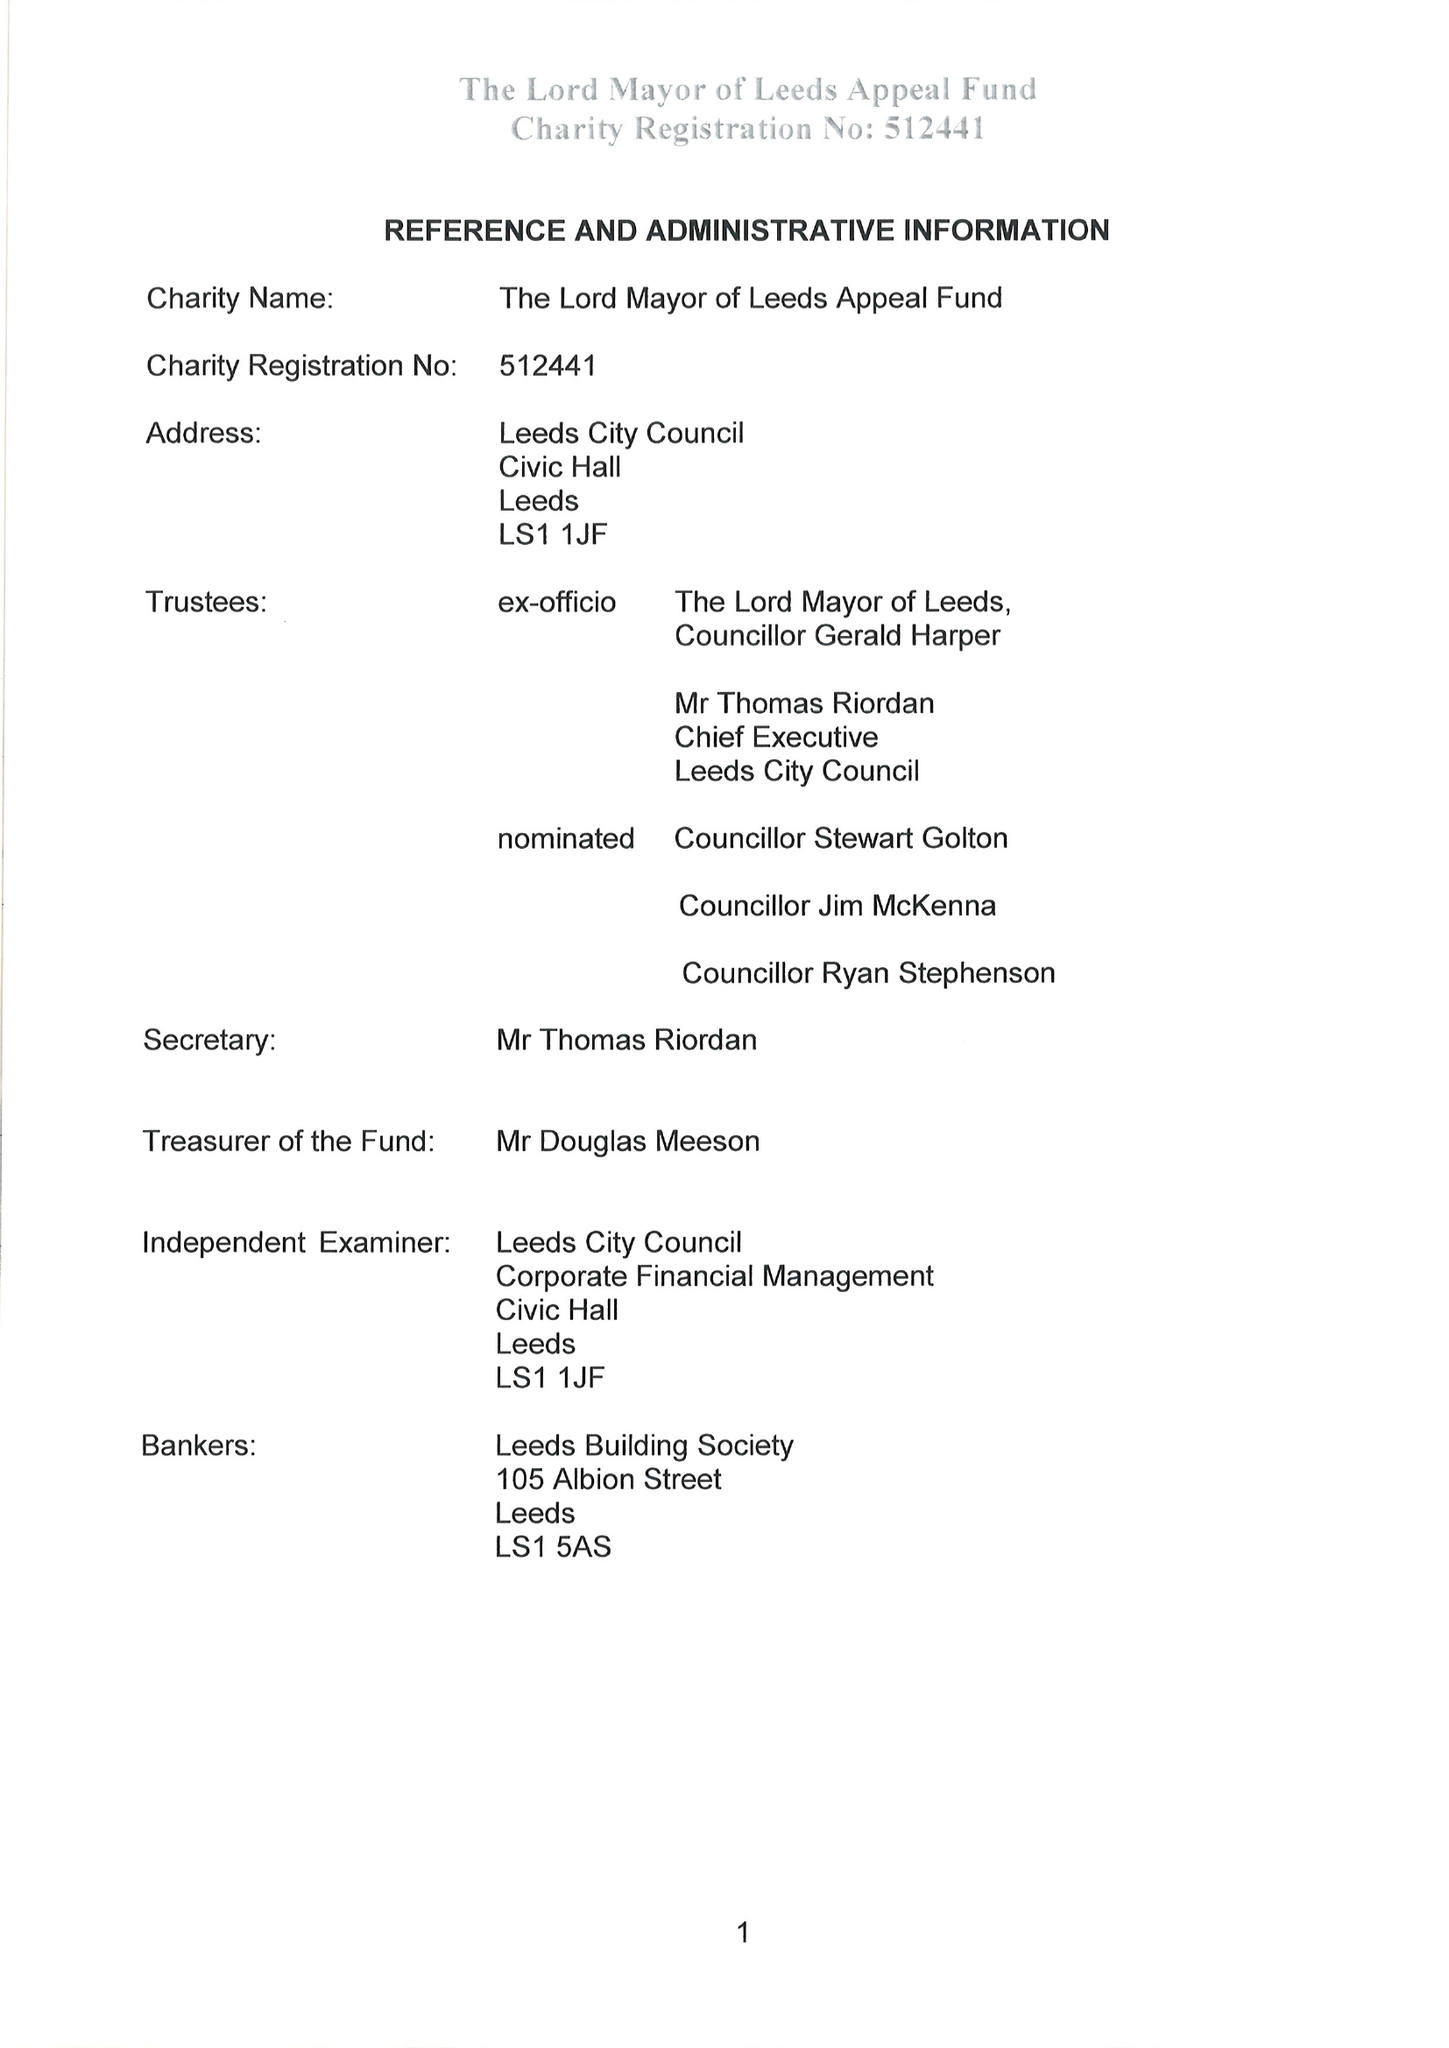What is the value for the charity_name?
Answer the question using a single word or phrase. Lord Mayor Of Leeds Appeal Fund 